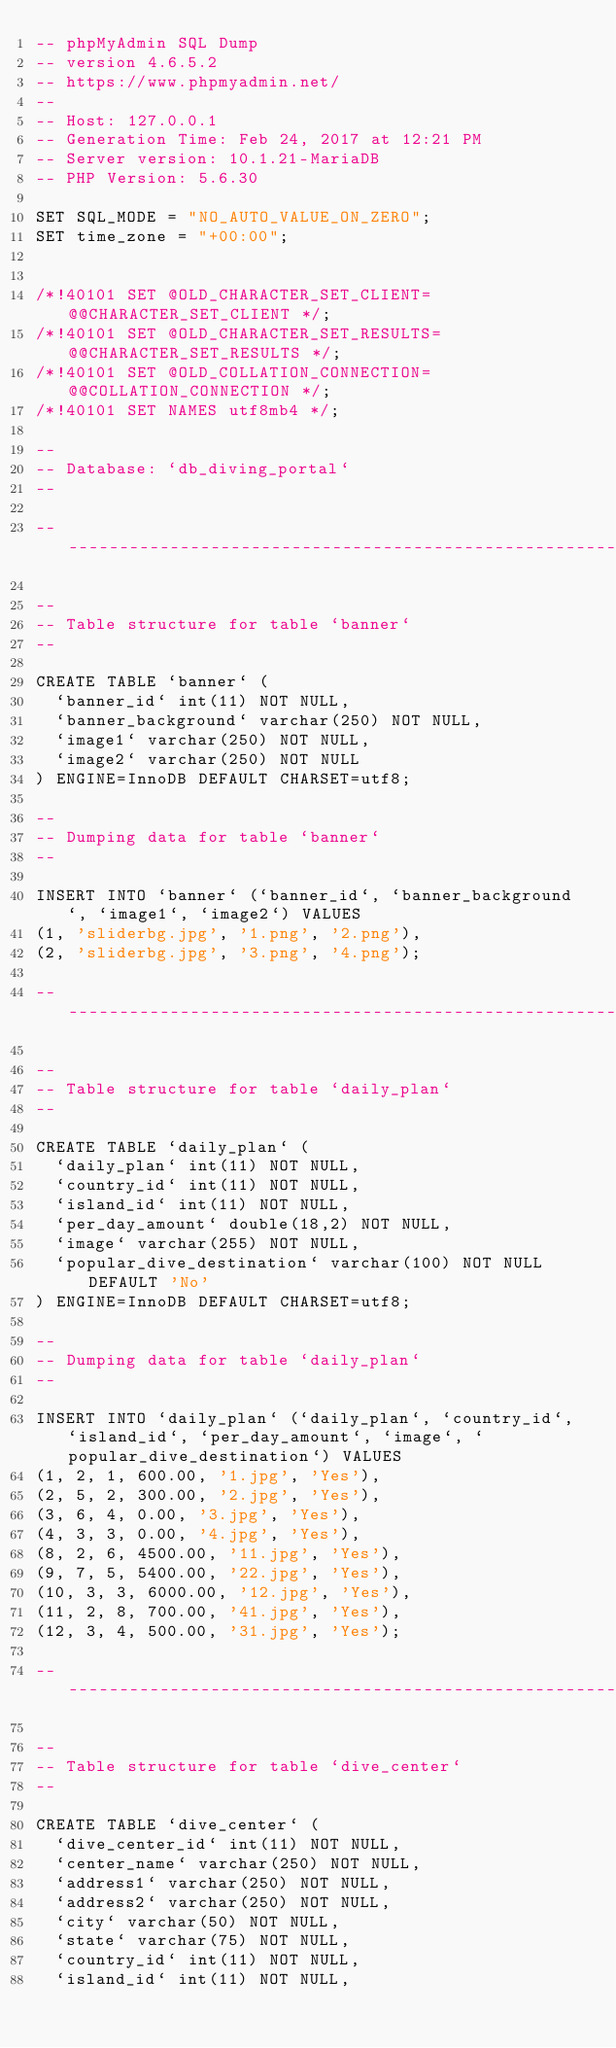Convert code to text. <code><loc_0><loc_0><loc_500><loc_500><_SQL_>-- phpMyAdmin SQL Dump
-- version 4.6.5.2
-- https://www.phpmyadmin.net/
--
-- Host: 127.0.0.1
-- Generation Time: Feb 24, 2017 at 12:21 PM
-- Server version: 10.1.21-MariaDB
-- PHP Version: 5.6.30

SET SQL_MODE = "NO_AUTO_VALUE_ON_ZERO";
SET time_zone = "+00:00";


/*!40101 SET @OLD_CHARACTER_SET_CLIENT=@@CHARACTER_SET_CLIENT */;
/*!40101 SET @OLD_CHARACTER_SET_RESULTS=@@CHARACTER_SET_RESULTS */;
/*!40101 SET @OLD_COLLATION_CONNECTION=@@COLLATION_CONNECTION */;
/*!40101 SET NAMES utf8mb4 */;

--
-- Database: `db_diving_portal`
--

-- --------------------------------------------------------

--
-- Table structure for table `banner`
--

CREATE TABLE `banner` (
  `banner_id` int(11) NOT NULL,
  `banner_background` varchar(250) NOT NULL,
  `image1` varchar(250) NOT NULL,
  `image2` varchar(250) NOT NULL
) ENGINE=InnoDB DEFAULT CHARSET=utf8;

--
-- Dumping data for table `banner`
--

INSERT INTO `banner` (`banner_id`, `banner_background`, `image1`, `image2`) VALUES
(1, 'sliderbg.jpg', '1.png', '2.png'),
(2, 'sliderbg.jpg', '3.png', '4.png');

-- --------------------------------------------------------

--
-- Table structure for table `daily_plan`
--

CREATE TABLE `daily_plan` (
  `daily_plan` int(11) NOT NULL,
  `country_id` int(11) NOT NULL,
  `island_id` int(11) NOT NULL,
  `per_day_amount` double(18,2) NOT NULL,
  `image` varchar(255) NOT NULL,
  `popular_dive_destination` varchar(100) NOT NULL DEFAULT 'No'
) ENGINE=InnoDB DEFAULT CHARSET=utf8;

--
-- Dumping data for table `daily_plan`
--

INSERT INTO `daily_plan` (`daily_plan`, `country_id`, `island_id`, `per_day_amount`, `image`, `popular_dive_destination`) VALUES
(1, 2, 1, 600.00, '1.jpg', 'Yes'),
(2, 5, 2, 300.00, '2.jpg', 'Yes'),
(3, 6, 4, 0.00, '3.jpg', 'Yes'),
(4, 3, 3, 0.00, '4.jpg', 'Yes'),
(8, 2, 6, 4500.00, '11.jpg', 'Yes'),
(9, 7, 5, 5400.00, '22.jpg', 'Yes'),
(10, 3, 3, 6000.00, '12.jpg', 'Yes'),
(11, 2, 8, 700.00, '41.jpg', 'Yes'),
(12, 3, 4, 500.00, '31.jpg', 'Yes');

-- --------------------------------------------------------

--
-- Table structure for table `dive_center`
--

CREATE TABLE `dive_center` (
  `dive_center_id` int(11) NOT NULL,
  `center_name` varchar(250) NOT NULL,
  `address1` varchar(250) NOT NULL,
  `address2` varchar(250) NOT NULL,
  `city` varchar(50) NOT NULL,
  `state` varchar(75) NOT NULL,
  `country_id` int(11) NOT NULL,
  `island_id` int(11) NOT NULL,</code> 